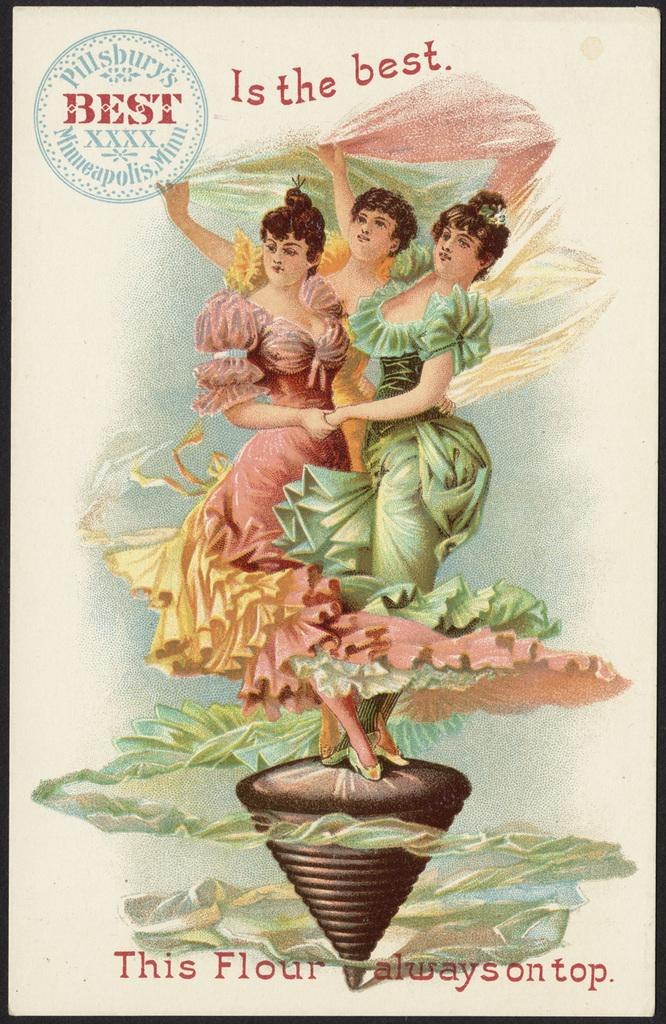<image>
Offer a succinct explanation of the picture presented. An old advertisement for Pillsbury's flour shows the logo "is the best." 